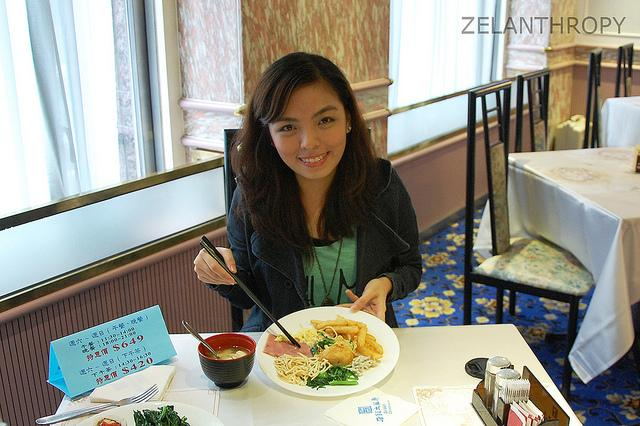Which city is most likely serving this restaurant? city 